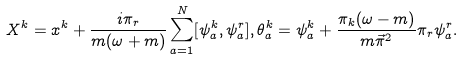<formula> <loc_0><loc_0><loc_500><loc_500>X ^ { k } = x ^ { k } + \frac { i \pi _ { r } } { m ( \omega + m ) } \sum _ { a = 1 } ^ { N } [ \psi _ { a } ^ { k } , \psi _ { a } ^ { r } ] , \theta _ { a } ^ { k } = \psi _ { a } ^ { k } + \frac { \pi _ { k } ( \omega - m ) } { m \vec { \pi } ^ { 2 } } \pi _ { r } \psi _ { a } ^ { r } .</formula> 